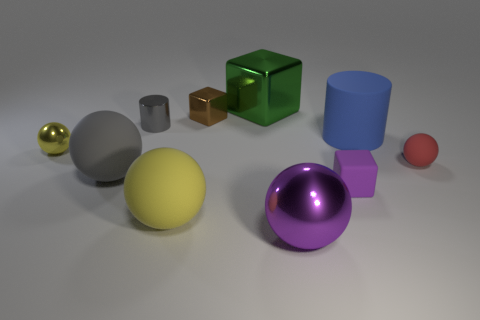Suppose I’m teaching a class about geometry, how could this image be useful? This image serves as an excellent visual aid for a geometry class; it showcases a variety of geometric shapes like spheres, a cylinder, and cubes. You could discuss properties of these shapes such as volume, surface area, and the differences between 2D and 3D shapes, illustrating real-world representations of geometric concepts. 